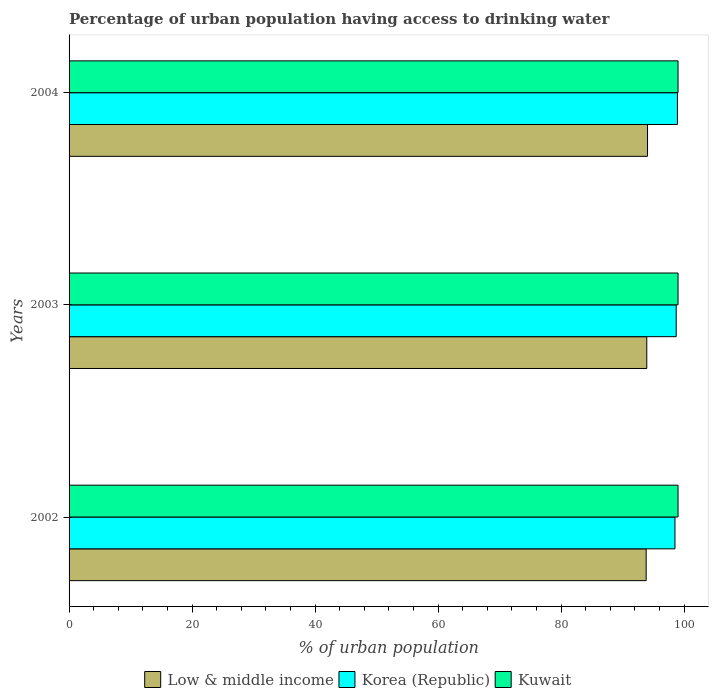How many groups of bars are there?
Offer a very short reply. 3. Are the number of bars per tick equal to the number of legend labels?
Offer a very short reply. Yes. How many bars are there on the 2nd tick from the top?
Provide a short and direct response. 3. How many bars are there on the 3rd tick from the bottom?
Make the answer very short. 3. In how many cases, is the number of bars for a given year not equal to the number of legend labels?
Your response must be concise. 0. What is the percentage of urban population having access to drinking water in Korea (Republic) in 2002?
Offer a very short reply. 98.5. Across all years, what is the maximum percentage of urban population having access to drinking water in Kuwait?
Ensure brevity in your answer.  99. Across all years, what is the minimum percentage of urban population having access to drinking water in Korea (Republic)?
Provide a short and direct response. 98.5. In which year was the percentage of urban population having access to drinking water in Korea (Republic) maximum?
Make the answer very short. 2004. In which year was the percentage of urban population having access to drinking water in Korea (Republic) minimum?
Your response must be concise. 2002. What is the total percentage of urban population having access to drinking water in Kuwait in the graph?
Ensure brevity in your answer.  297. What is the difference between the percentage of urban population having access to drinking water in Korea (Republic) in 2002 and that in 2004?
Your answer should be compact. -0.4. What is the difference between the percentage of urban population having access to drinking water in Korea (Republic) in 2003 and the percentage of urban population having access to drinking water in Low & middle income in 2002?
Ensure brevity in your answer.  4.88. In the year 2003, what is the difference between the percentage of urban population having access to drinking water in Kuwait and percentage of urban population having access to drinking water in Low & middle income?
Keep it short and to the point. 5.08. What is the ratio of the percentage of urban population having access to drinking water in Korea (Republic) in 2002 to that in 2003?
Offer a terse response. 1. Is the difference between the percentage of urban population having access to drinking water in Kuwait in 2003 and 2004 greater than the difference between the percentage of urban population having access to drinking water in Low & middle income in 2003 and 2004?
Your response must be concise. Yes. What is the difference between the highest and the second highest percentage of urban population having access to drinking water in Kuwait?
Your answer should be very brief. 0. What is the difference between the highest and the lowest percentage of urban population having access to drinking water in Kuwait?
Keep it short and to the point. 0. In how many years, is the percentage of urban population having access to drinking water in Kuwait greater than the average percentage of urban population having access to drinking water in Kuwait taken over all years?
Offer a terse response. 0. What does the 2nd bar from the top in 2003 represents?
Make the answer very short. Korea (Republic). How many bars are there?
Your response must be concise. 9. Are all the bars in the graph horizontal?
Keep it short and to the point. Yes. What is the difference between two consecutive major ticks on the X-axis?
Offer a terse response. 20. Are the values on the major ticks of X-axis written in scientific E-notation?
Your answer should be compact. No. How many legend labels are there?
Your answer should be compact. 3. How are the legend labels stacked?
Give a very brief answer. Horizontal. What is the title of the graph?
Provide a short and direct response. Percentage of urban population having access to drinking water. Does "Middle income" appear as one of the legend labels in the graph?
Your answer should be compact. No. What is the label or title of the X-axis?
Offer a terse response. % of urban population. What is the label or title of the Y-axis?
Your answer should be very brief. Years. What is the % of urban population of Low & middle income in 2002?
Your response must be concise. 93.82. What is the % of urban population of Korea (Republic) in 2002?
Offer a terse response. 98.5. What is the % of urban population in Low & middle income in 2003?
Keep it short and to the point. 93.92. What is the % of urban population of Korea (Republic) in 2003?
Provide a succinct answer. 98.7. What is the % of urban population of Low & middle income in 2004?
Your answer should be very brief. 94.04. What is the % of urban population of Korea (Republic) in 2004?
Your response must be concise. 98.9. Across all years, what is the maximum % of urban population of Low & middle income?
Provide a succinct answer. 94.04. Across all years, what is the maximum % of urban population in Korea (Republic)?
Provide a succinct answer. 98.9. Across all years, what is the maximum % of urban population of Kuwait?
Offer a very short reply. 99. Across all years, what is the minimum % of urban population in Low & middle income?
Offer a very short reply. 93.82. Across all years, what is the minimum % of urban population of Korea (Republic)?
Offer a terse response. 98.5. Across all years, what is the minimum % of urban population of Kuwait?
Your answer should be compact. 99. What is the total % of urban population in Low & middle income in the graph?
Your response must be concise. 281.78. What is the total % of urban population in Korea (Republic) in the graph?
Your answer should be very brief. 296.1. What is the total % of urban population in Kuwait in the graph?
Offer a terse response. 297. What is the difference between the % of urban population of Low & middle income in 2002 and that in 2004?
Offer a terse response. -0.22. What is the difference between the % of urban population of Kuwait in 2002 and that in 2004?
Your response must be concise. 0. What is the difference between the % of urban population in Low & middle income in 2003 and that in 2004?
Offer a very short reply. -0.12. What is the difference between the % of urban population of Low & middle income in 2002 and the % of urban population of Korea (Republic) in 2003?
Give a very brief answer. -4.88. What is the difference between the % of urban population in Low & middle income in 2002 and the % of urban population in Kuwait in 2003?
Give a very brief answer. -5.18. What is the difference between the % of urban population in Korea (Republic) in 2002 and the % of urban population in Kuwait in 2003?
Offer a terse response. -0.5. What is the difference between the % of urban population in Low & middle income in 2002 and the % of urban population in Korea (Republic) in 2004?
Offer a terse response. -5.08. What is the difference between the % of urban population in Low & middle income in 2002 and the % of urban population in Kuwait in 2004?
Your answer should be very brief. -5.18. What is the difference between the % of urban population of Korea (Republic) in 2002 and the % of urban population of Kuwait in 2004?
Your answer should be very brief. -0.5. What is the difference between the % of urban population of Low & middle income in 2003 and the % of urban population of Korea (Republic) in 2004?
Make the answer very short. -4.98. What is the difference between the % of urban population of Low & middle income in 2003 and the % of urban population of Kuwait in 2004?
Your answer should be very brief. -5.08. What is the difference between the % of urban population of Korea (Republic) in 2003 and the % of urban population of Kuwait in 2004?
Provide a short and direct response. -0.3. What is the average % of urban population in Low & middle income per year?
Ensure brevity in your answer.  93.93. What is the average % of urban population of Korea (Republic) per year?
Make the answer very short. 98.7. In the year 2002, what is the difference between the % of urban population of Low & middle income and % of urban population of Korea (Republic)?
Keep it short and to the point. -4.68. In the year 2002, what is the difference between the % of urban population in Low & middle income and % of urban population in Kuwait?
Ensure brevity in your answer.  -5.18. In the year 2002, what is the difference between the % of urban population of Korea (Republic) and % of urban population of Kuwait?
Make the answer very short. -0.5. In the year 2003, what is the difference between the % of urban population in Low & middle income and % of urban population in Korea (Republic)?
Your response must be concise. -4.78. In the year 2003, what is the difference between the % of urban population in Low & middle income and % of urban population in Kuwait?
Your answer should be very brief. -5.08. In the year 2003, what is the difference between the % of urban population of Korea (Republic) and % of urban population of Kuwait?
Provide a short and direct response. -0.3. In the year 2004, what is the difference between the % of urban population of Low & middle income and % of urban population of Korea (Republic)?
Your response must be concise. -4.86. In the year 2004, what is the difference between the % of urban population in Low & middle income and % of urban population in Kuwait?
Give a very brief answer. -4.96. What is the ratio of the % of urban population of Low & middle income in 2002 to that in 2003?
Provide a succinct answer. 1. What is the ratio of the % of urban population in Korea (Republic) in 2002 to that in 2003?
Make the answer very short. 1. What is the ratio of the % of urban population of Kuwait in 2002 to that in 2003?
Offer a very short reply. 1. What is the ratio of the % of urban population of Low & middle income in 2002 to that in 2004?
Keep it short and to the point. 1. What is the ratio of the % of urban population of Korea (Republic) in 2002 to that in 2004?
Offer a very short reply. 1. What is the ratio of the % of urban population in Low & middle income in 2003 to that in 2004?
Your response must be concise. 1. What is the ratio of the % of urban population of Kuwait in 2003 to that in 2004?
Your answer should be very brief. 1. What is the difference between the highest and the second highest % of urban population in Low & middle income?
Your response must be concise. 0.12. What is the difference between the highest and the lowest % of urban population of Low & middle income?
Your answer should be very brief. 0.22. What is the difference between the highest and the lowest % of urban population in Kuwait?
Offer a very short reply. 0. 